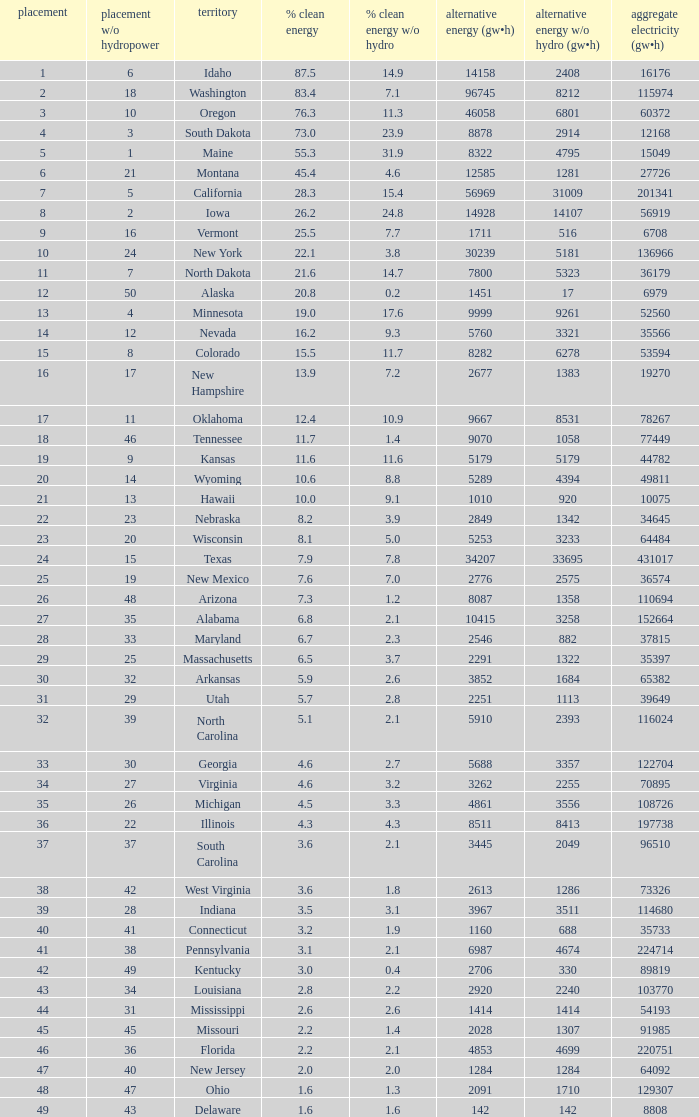When renewable electricity is 5760 (gw×h) what is the minimum amount of renewable elecrrixity without hydrogen power? 3321.0. 